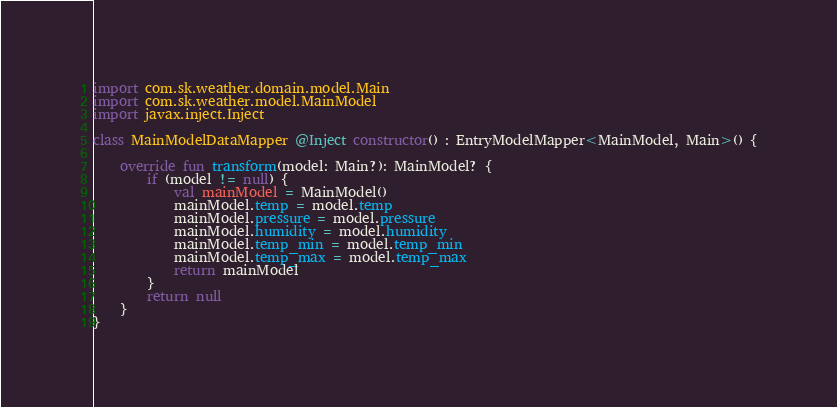<code> <loc_0><loc_0><loc_500><loc_500><_Kotlin_>
import com.sk.weather.domain.model.Main
import com.sk.weather.model.MainModel
import javax.inject.Inject

class MainModelDataMapper @Inject constructor() : EntryModelMapper<MainModel, Main>() {

    override fun transform(model: Main?): MainModel? {
        if (model != null) {
            val mainModel = MainModel()
            mainModel.temp = model.temp
            mainModel.pressure = model.pressure
            mainModel.humidity = model.humidity
            mainModel.temp_min = model.temp_min
            mainModel.temp_max = model.temp_max
            return mainModel
        }
        return null
    }
}</code> 